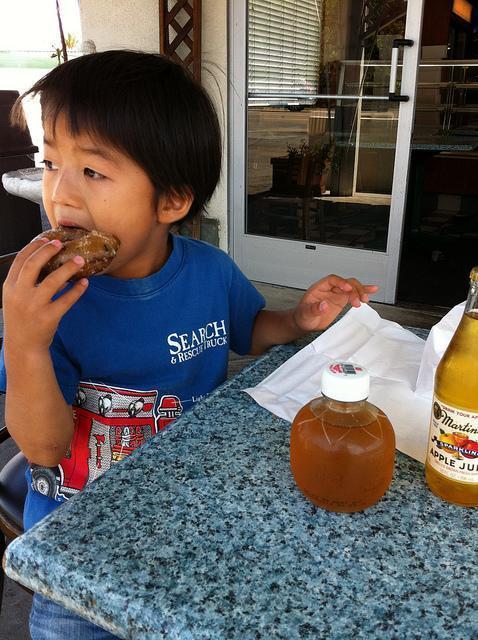How many different drinks are there?
Give a very brief answer. 2. How many bottles are in the picture?
Give a very brief answer. 2. 